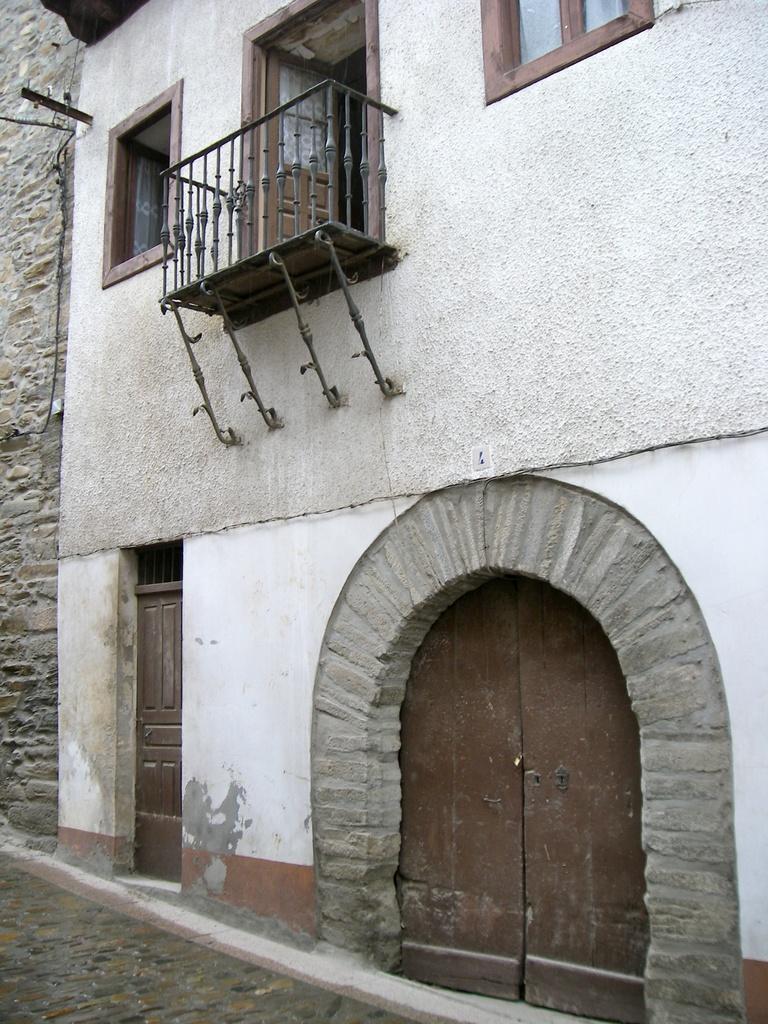In one or two sentences, can you explain what this image depicts? In this image we can see a building, there are some windows, doors and grille. 